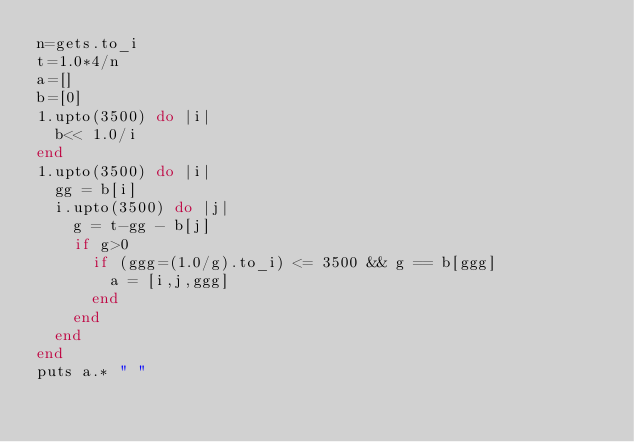Convert code to text. <code><loc_0><loc_0><loc_500><loc_500><_Ruby_>n=gets.to_i
t=1.0*4/n
a=[]
b=[0]
1.upto(3500) do |i|
  b<< 1.0/i
end
1.upto(3500) do |i|
  gg = b[i]
  i.upto(3500) do |j|
    g = t-gg - b[j]
    if g>0
      if (ggg=(1.0/g).to_i) <= 3500 && g == b[ggg]
        a = [i,j,ggg]
      end
    end
  end
end
puts a.* " "
</code> 